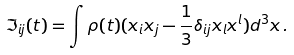<formula> <loc_0><loc_0><loc_500><loc_500>\Im _ { i j } ( t ) = \int \rho ( t ) ( x _ { i } x _ { j } - \frac { 1 } { 3 } \delta _ { i j } x _ { l } x ^ { l } ) d ^ { 3 } x \, .</formula> 